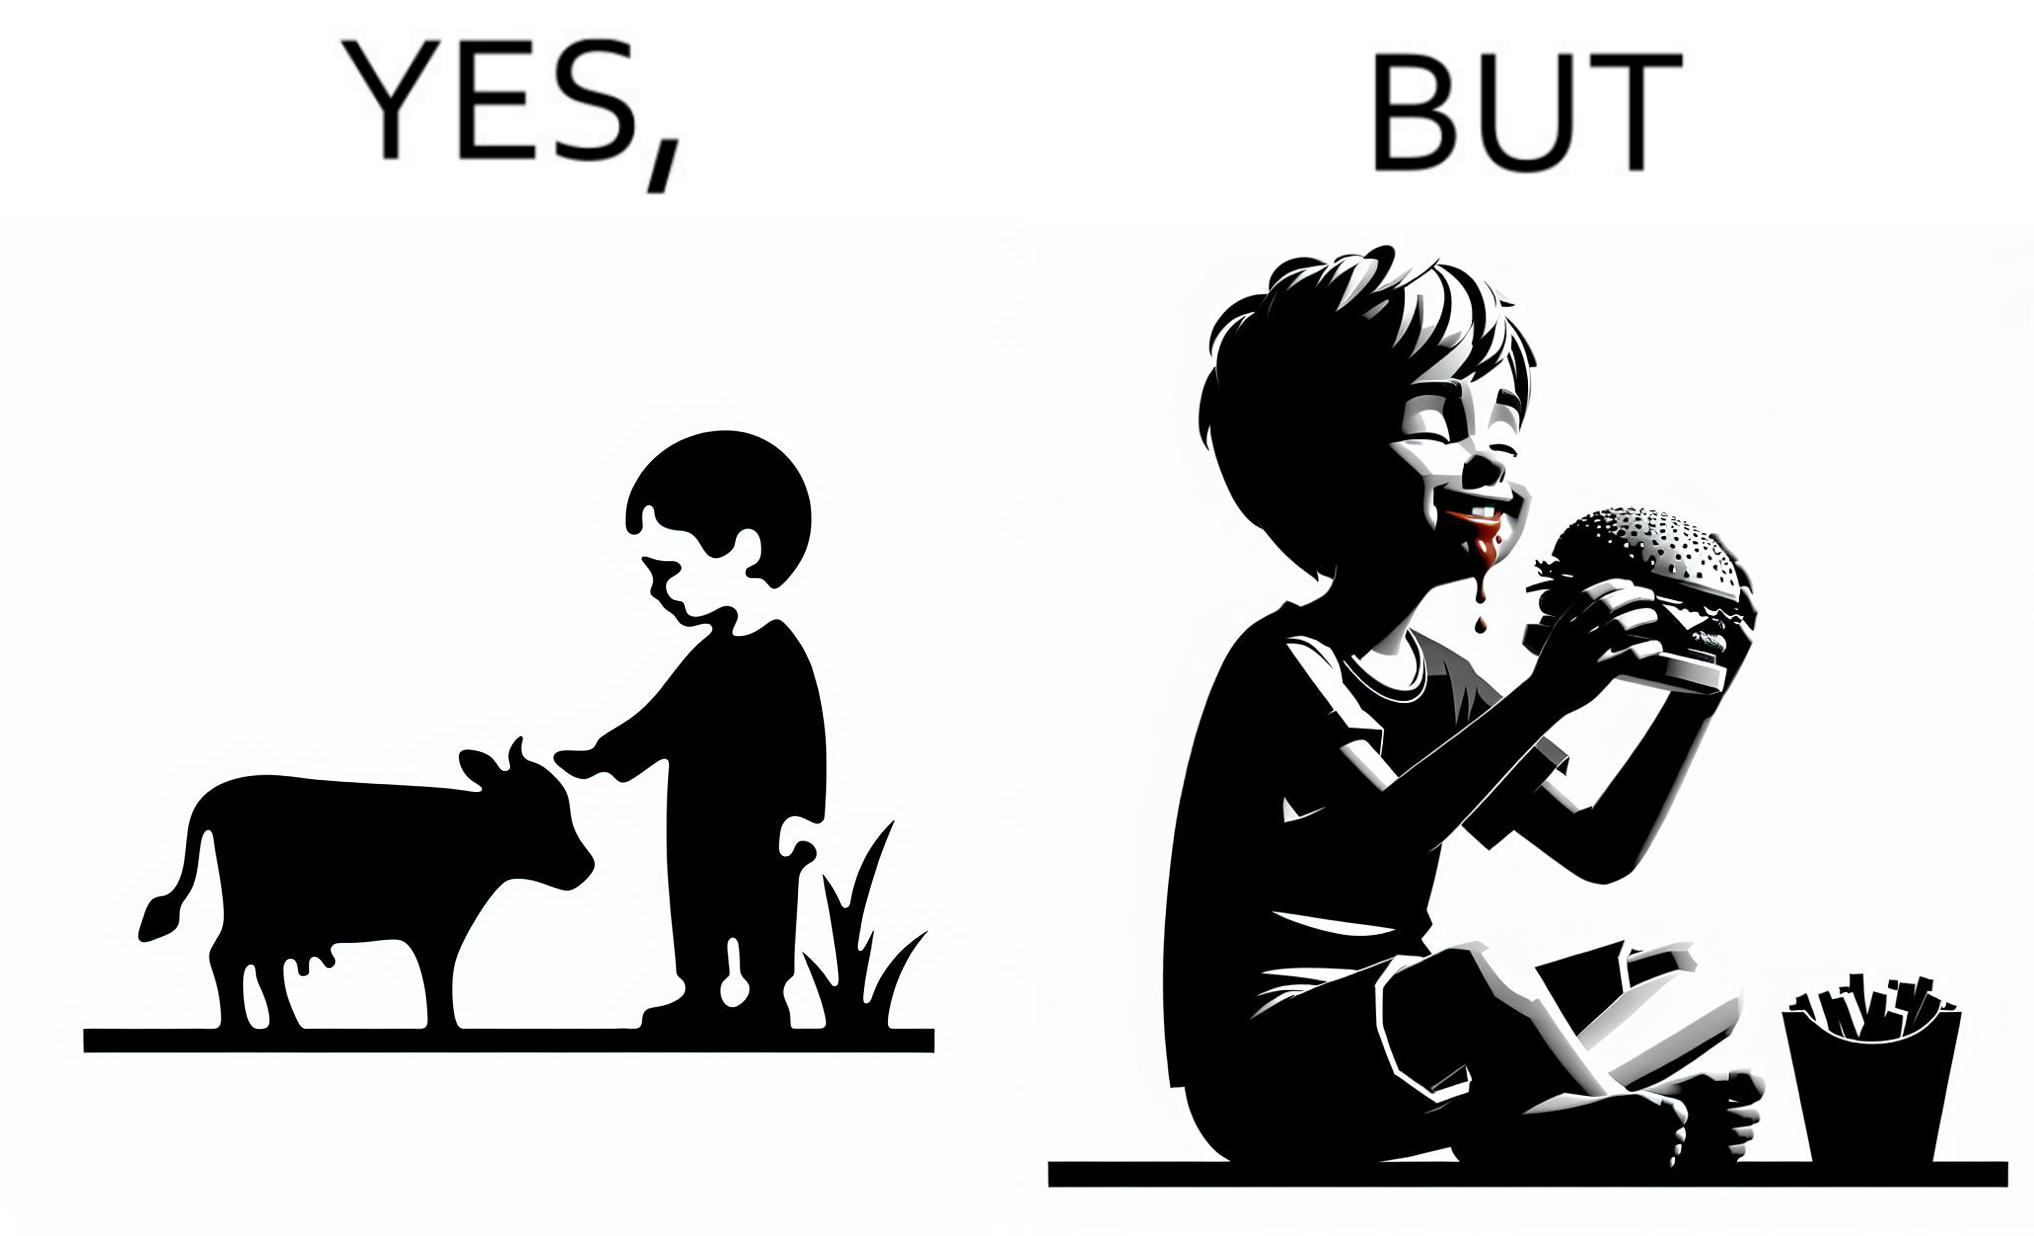Explain why this image is satirical. The irony is that the boy is petting the cow to show that he cares about the animal, but then he also eats hamburgers made from the same cows 